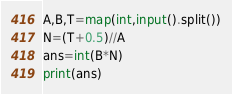<code> <loc_0><loc_0><loc_500><loc_500><_Python_>A,B,T=map(int,input().split())
N=(T+0.5)//A
ans=int(B*N)
print(ans)</code> 